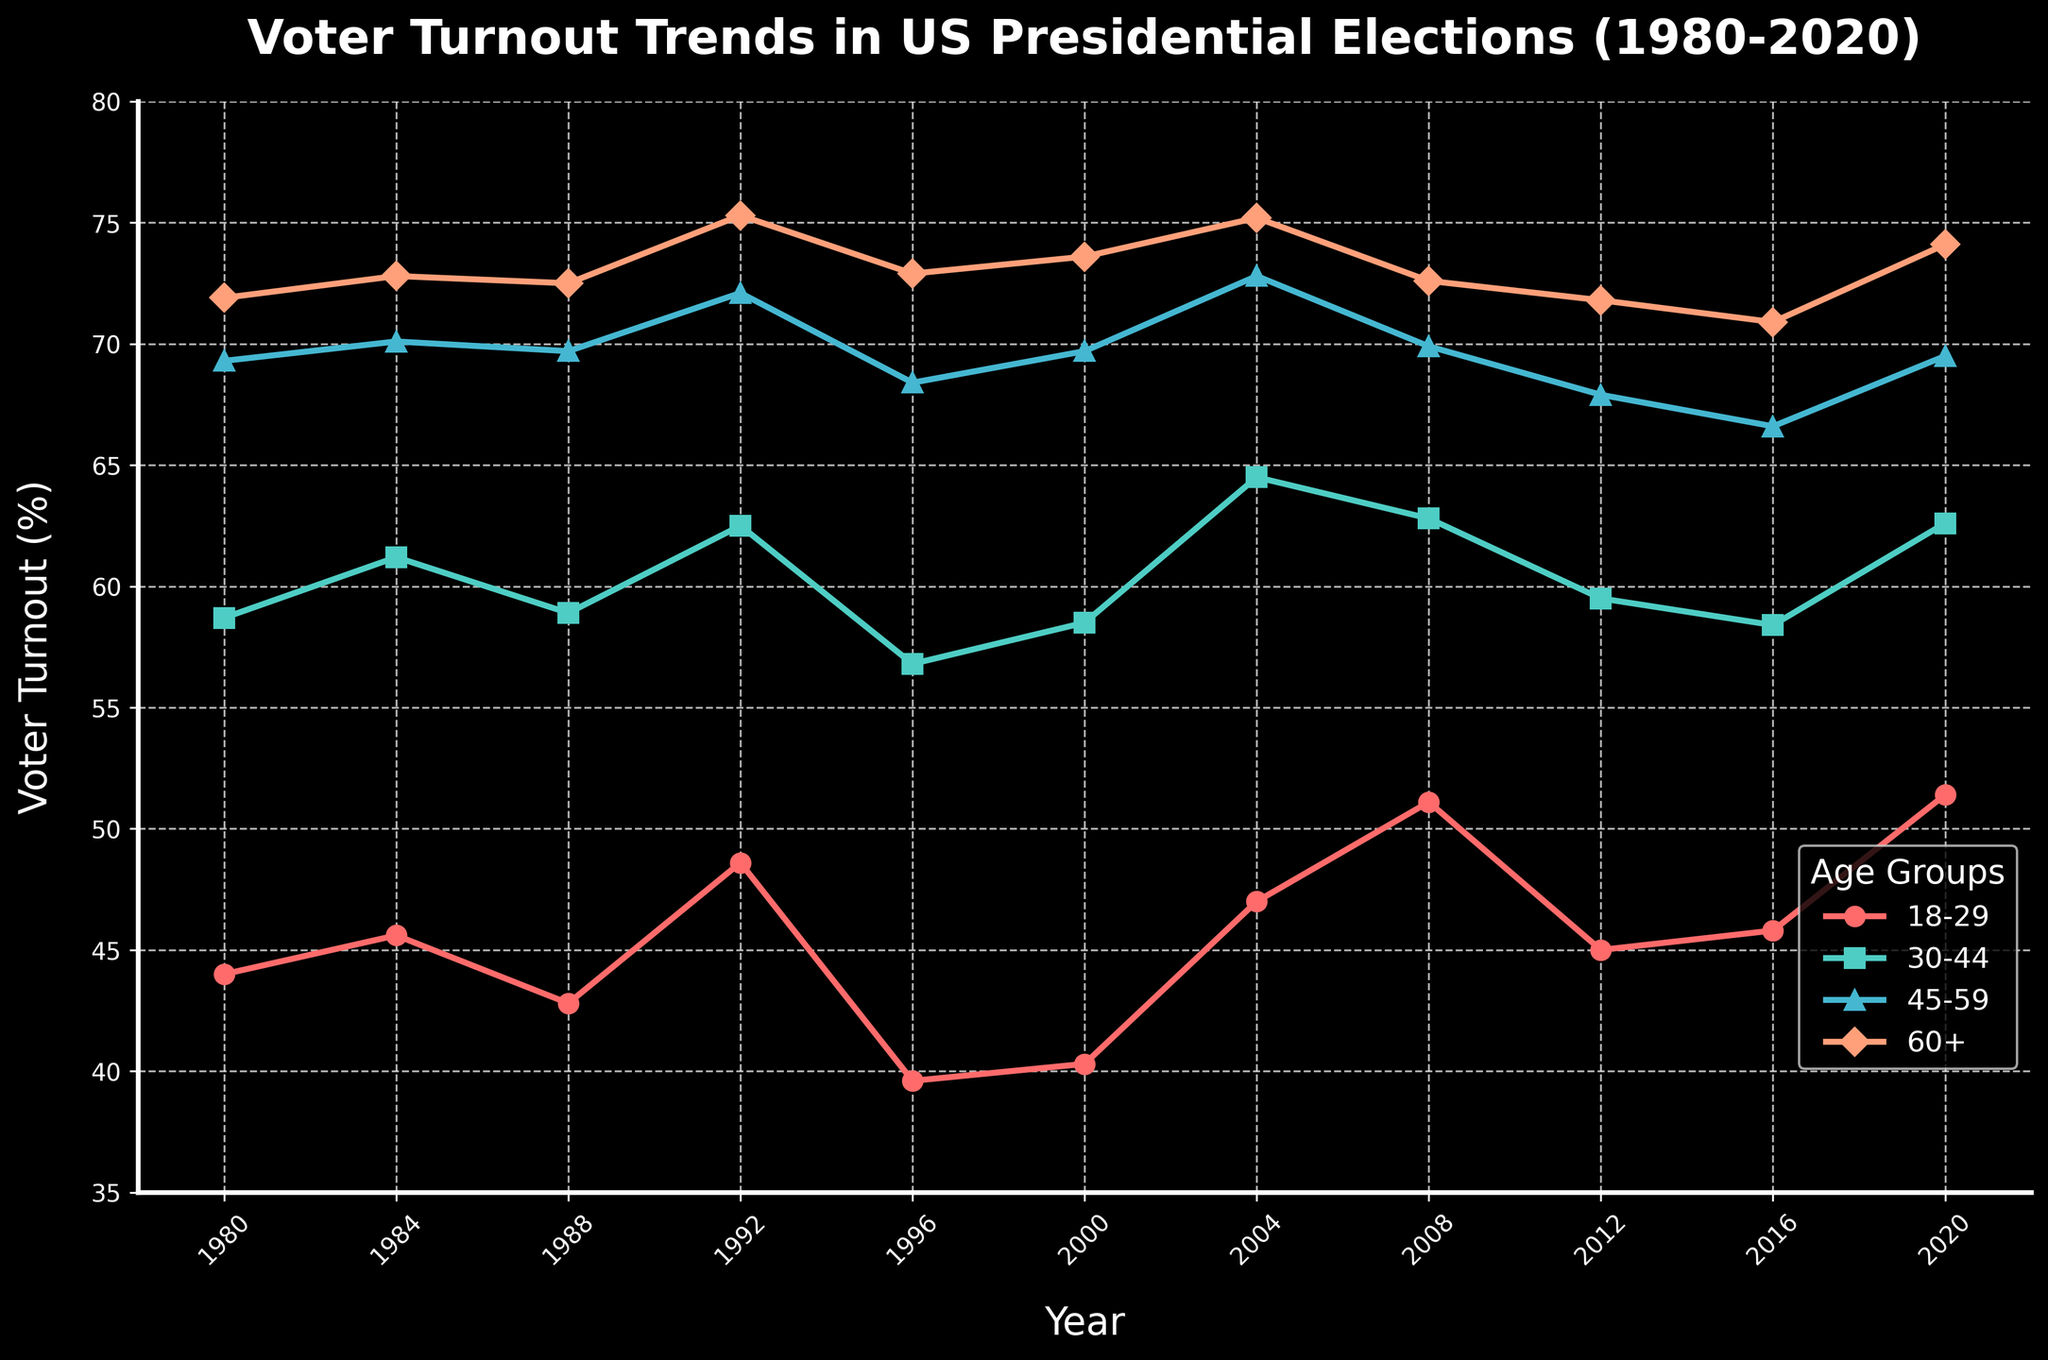Which age group consistently had the highest voter turnout from 1980 to 2020? From the figure, it is evident that the 60+ age group consistently had the highest voter turnout in each presidential election year between 1980 and 2020. This can be seen by comparing the different lines, where the line representing the 60+ age group is consistently higher than the others.
Answer: 60+ age group In which year did the 18-29 age group's voter turnout reach its highest value? The 18-29 age group's voter turnout reached its highest value in the year 2020. This can be observed by locating the peak of the curve for the 18-29 category, which is at its maximum value in 2020.
Answer: 2020 How did the voter turnout for the 30-44 age group change from 1996 to 2004? To find the change in voter turnout for the 30-44 age group from 1996 to 2004, we look at the figure and note the values for these years: in 1996, it was 56.8%, and in 2004, it increased to 64.5%. The change in voter turnout is 64.5% - 56.8% = 7.7%.
Answer: Increased by 7.7% Between 1984 and 2000, which age group experienced the least variation in voter turnout? To determine the least variation, we examine the voter turnout values between 1984 and 2000 for all age groups. The 60+ age group has values of 72.8%, 72.5%, 75.3%, 72.9%, and 73.6%, showing the smallest range of 72.5% to 75.3%, a variation of 2.8%. Other age groups displayed higher variations.
Answer: 60+ age group What is the average voter turnout for the 45-59 age group across all years? To find the average, sum the voter turnout percentages for the 45-59 age group across all years and divide by the number of years: 
(69.3 + 70.1 + 69.7 + 72.1 + 68.4 + 69.7 + 72.8 + 69.9 + 67.9 + 66.6 + 69.5) / 11 = 686 / 11 = 62.36%.
Answer: 69.6% By how much did the voter turnout for the 18-29 age group increase between 2016 and 2020? To find the increase, note the voter turnout for the 18-29 age group in 2016 (45.8%) and in 2020 (51.4%). The increase is 51.4% - 45.8% = 5.6%.
Answer: Increased by 5.6% Which year saw the sharpest decline in voter turnout for the 30-44 age group? To determine the sharpest decline, compare the voter turnout percentages year-to-year for the 30-44 age group. The sharpest decline occurred between 1992 (62.5%) and 1996 (56.8%), a decrease of 62.5% - 56.8% = 5.7%.
Answer: Between 1992 and 1996 In which year did the voter turnout for all age groups increase compared to the previous election year? The figure shows that voter turnout for all age groups increased between the year 2000 and 2004. Each age group's turnout moved upward compared to the previous year.
Answer: 2004 Which age group had the most significant overall voter turnout increase from 1980 to 2020? Calculate the overall increase for each age group by comparing the voter turnout in 1980 to 2020. The 18-29 age group had the most significant increase: 51.4% (2020) - 44.0% (1980) = 7.4%.
Answer: 18-29 age group 